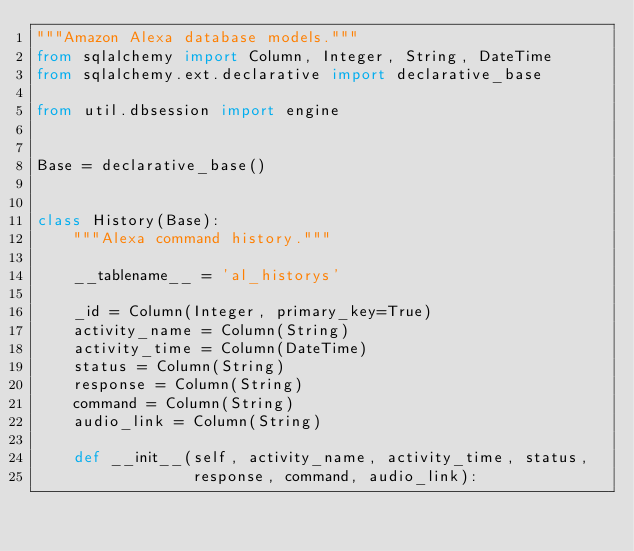Convert code to text. <code><loc_0><loc_0><loc_500><loc_500><_Python_>"""Amazon Alexa database models."""
from sqlalchemy import Column, Integer, String, DateTime
from sqlalchemy.ext.declarative import declarative_base

from util.dbsession import engine


Base = declarative_base()


class History(Base):
    """Alexa command history."""

    __tablename__ = 'al_historys'

    _id = Column(Integer, primary_key=True)
    activity_name = Column(String)
    activity_time = Column(DateTime)
    status = Column(String)
    response = Column(String)
    command = Column(String)
    audio_link = Column(String)

    def __init__(self, activity_name, activity_time, status,
                 response, command, audio_link):</code> 